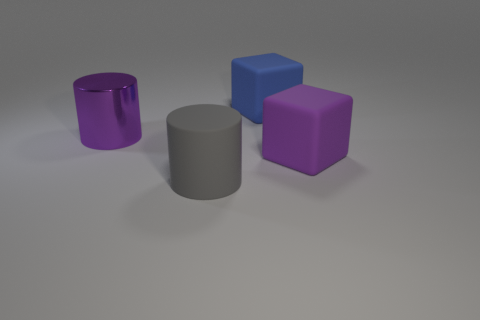What number of rubber cubes have the same color as the shiny object?
Provide a succinct answer. 1. There is a metallic thing; is its color the same as the block in front of the blue object?
Give a very brief answer. Yes. Do the large matte thing that is to the right of the blue block and the metallic object have the same color?
Keep it short and to the point. Yes. There is a large thing that is both behind the purple matte object and in front of the blue cube; what material is it?
Give a very brief answer. Metal. There is a big object that is the same color as the metal cylinder; what is its shape?
Your response must be concise. Cube. What number of other large metal things are the same shape as the large blue object?
Your answer should be very brief. 0. Are any brown matte cubes visible?
Provide a succinct answer. No. There is a cube that is right of the large cube behind the big purple thing that is left of the gray cylinder; how big is it?
Your answer should be compact. Large. How many blue things have the same material as the big purple block?
Keep it short and to the point. 1. How many other blue shiny cylinders have the same size as the metallic cylinder?
Your answer should be compact. 0. 